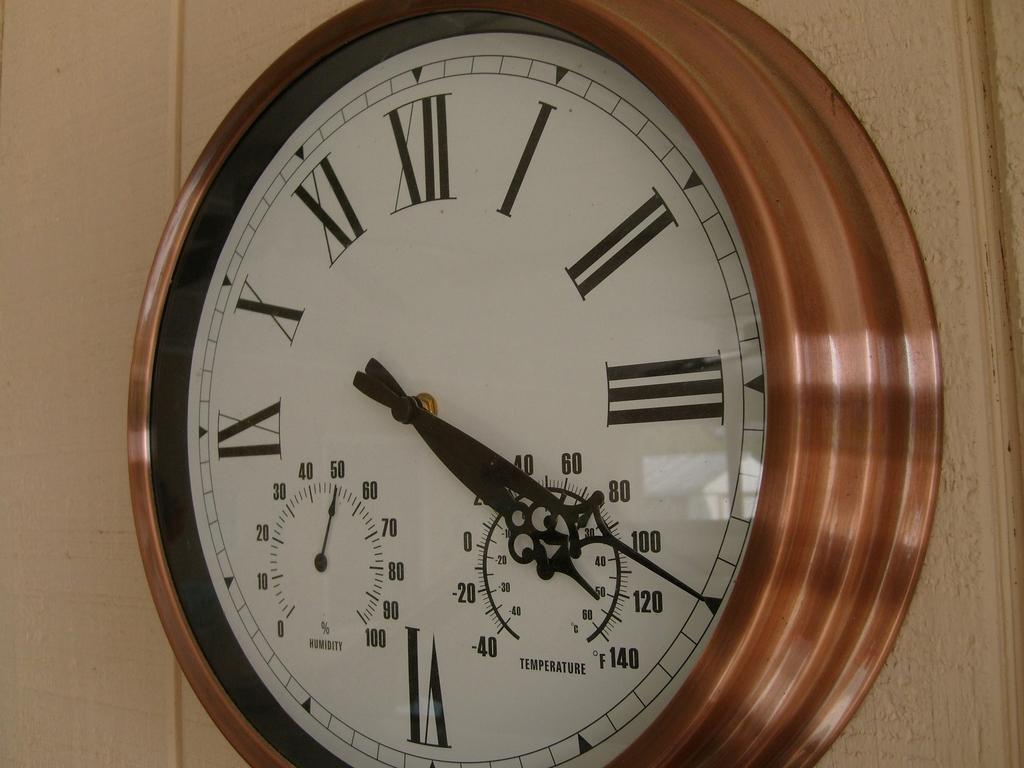What temperature does the clock max out at?
Make the answer very short. 140. 